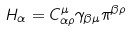Convert formula to latex. <formula><loc_0><loc_0><loc_500><loc_500>H _ { \alpha } = C ^ { \mu } _ { \alpha \rho } \gamma _ { \beta \mu } \pi ^ { \beta \rho }</formula> 